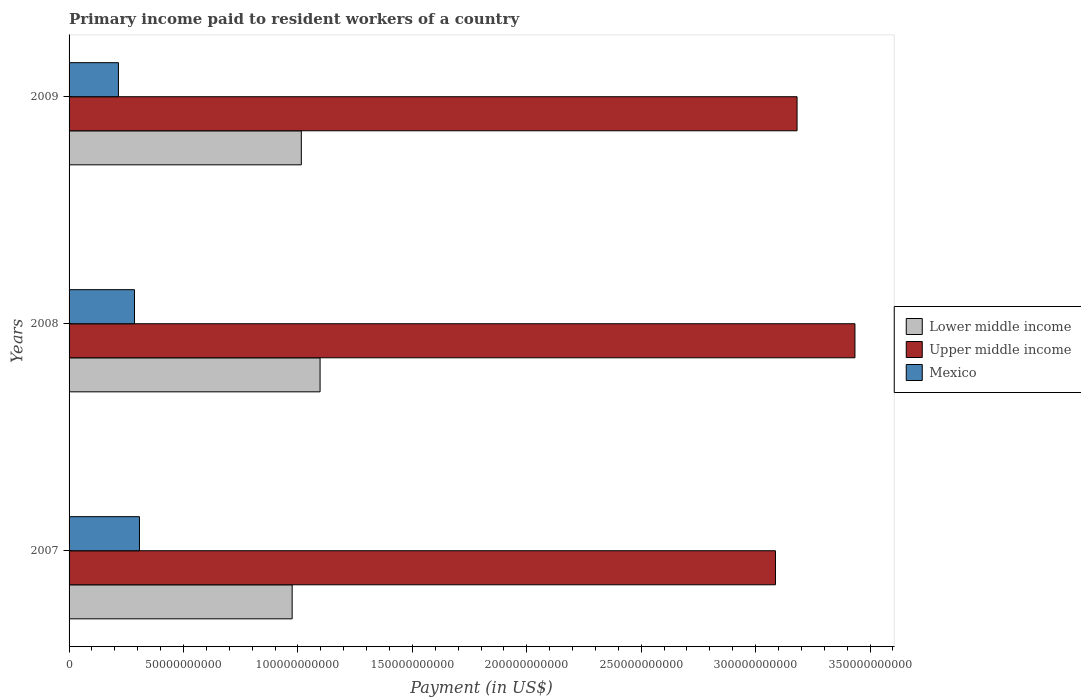How many different coloured bars are there?
Offer a very short reply. 3. How many groups of bars are there?
Make the answer very short. 3. How many bars are there on the 3rd tick from the top?
Give a very brief answer. 3. What is the label of the 2nd group of bars from the top?
Give a very brief answer. 2008. What is the amount paid to workers in Upper middle income in 2008?
Your answer should be very brief. 3.43e+11. Across all years, what is the maximum amount paid to workers in Mexico?
Your answer should be compact. 3.08e+1. Across all years, what is the minimum amount paid to workers in Lower middle income?
Your answer should be very brief. 9.75e+1. In which year was the amount paid to workers in Lower middle income maximum?
Your answer should be compact. 2008. What is the total amount paid to workers in Lower middle income in the graph?
Give a very brief answer. 3.09e+11. What is the difference between the amount paid to workers in Upper middle income in 2007 and that in 2008?
Ensure brevity in your answer.  -3.47e+1. What is the difference between the amount paid to workers in Lower middle income in 2009 and the amount paid to workers in Mexico in 2008?
Make the answer very short. 7.29e+1. What is the average amount paid to workers in Upper middle income per year?
Provide a short and direct response. 3.23e+11. In the year 2007, what is the difference between the amount paid to workers in Upper middle income and amount paid to workers in Mexico?
Provide a succinct answer. 2.78e+11. In how many years, is the amount paid to workers in Upper middle income greater than 110000000000 US$?
Offer a very short reply. 3. What is the ratio of the amount paid to workers in Upper middle income in 2007 to that in 2008?
Offer a terse response. 0.9. Is the amount paid to workers in Upper middle income in 2007 less than that in 2009?
Your response must be concise. Yes. What is the difference between the highest and the second highest amount paid to workers in Upper middle income?
Offer a very short reply. 2.53e+1. What is the difference between the highest and the lowest amount paid to workers in Upper middle income?
Your answer should be very brief. 3.47e+1. In how many years, is the amount paid to workers in Lower middle income greater than the average amount paid to workers in Lower middle income taken over all years?
Your answer should be compact. 1. Is the sum of the amount paid to workers in Lower middle income in 2007 and 2009 greater than the maximum amount paid to workers in Mexico across all years?
Give a very brief answer. Yes. What does the 3rd bar from the top in 2009 represents?
Your answer should be very brief. Lower middle income. What does the 2nd bar from the bottom in 2008 represents?
Offer a terse response. Upper middle income. Are the values on the major ticks of X-axis written in scientific E-notation?
Provide a short and direct response. No. Where does the legend appear in the graph?
Make the answer very short. Center right. How are the legend labels stacked?
Offer a terse response. Vertical. What is the title of the graph?
Provide a succinct answer. Primary income paid to resident workers of a country. Does "Peru" appear as one of the legend labels in the graph?
Provide a succinct answer. No. What is the label or title of the X-axis?
Your response must be concise. Payment (in US$). What is the Payment (in US$) of Lower middle income in 2007?
Ensure brevity in your answer.  9.75e+1. What is the Payment (in US$) of Upper middle income in 2007?
Your answer should be compact. 3.09e+11. What is the Payment (in US$) in Mexico in 2007?
Provide a short and direct response. 3.08e+1. What is the Payment (in US$) in Lower middle income in 2008?
Keep it short and to the point. 1.10e+11. What is the Payment (in US$) of Upper middle income in 2008?
Your response must be concise. 3.43e+11. What is the Payment (in US$) in Mexico in 2008?
Provide a short and direct response. 2.86e+1. What is the Payment (in US$) of Lower middle income in 2009?
Offer a very short reply. 1.01e+11. What is the Payment (in US$) of Upper middle income in 2009?
Your response must be concise. 3.18e+11. What is the Payment (in US$) in Mexico in 2009?
Provide a short and direct response. 2.16e+1. Across all years, what is the maximum Payment (in US$) in Lower middle income?
Your response must be concise. 1.10e+11. Across all years, what is the maximum Payment (in US$) of Upper middle income?
Your answer should be very brief. 3.43e+11. Across all years, what is the maximum Payment (in US$) of Mexico?
Make the answer very short. 3.08e+1. Across all years, what is the minimum Payment (in US$) of Lower middle income?
Give a very brief answer. 9.75e+1. Across all years, what is the minimum Payment (in US$) in Upper middle income?
Offer a very short reply. 3.09e+11. Across all years, what is the minimum Payment (in US$) in Mexico?
Provide a succinct answer. 2.16e+1. What is the total Payment (in US$) of Lower middle income in the graph?
Make the answer very short. 3.09e+11. What is the total Payment (in US$) of Upper middle income in the graph?
Your response must be concise. 9.70e+11. What is the total Payment (in US$) of Mexico in the graph?
Your answer should be compact. 8.09e+1. What is the difference between the Payment (in US$) of Lower middle income in 2007 and that in 2008?
Your answer should be very brief. -1.22e+1. What is the difference between the Payment (in US$) in Upper middle income in 2007 and that in 2008?
Your answer should be compact. -3.47e+1. What is the difference between the Payment (in US$) in Mexico in 2007 and that in 2008?
Keep it short and to the point. 2.18e+09. What is the difference between the Payment (in US$) of Lower middle income in 2007 and that in 2009?
Make the answer very short. -4.01e+09. What is the difference between the Payment (in US$) in Upper middle income in 2007 and that in 2009?
Your answer should be very brief. -9.44e+09. What is the difference between the Payment (in US$) in Mexico in 2007 and that in 2009?
Ensure brevity in your answer.  9.19e+09. What is the difference between the Payment (in US$) of Lower middle income in 2008 and that in 2009?
Offer a very short reply. 8.19e+09. What is the difference between the Payment (in US$) in Upper middle income in 2008 and that in 2009?
Make the answer very short. 2.53e+1. What is the difference between the Payment (in US$) of Mexico in 2008 and that in 2009?
Keep it short and to the point. 7.01e+09. What is the difference between the Payment (in US$) of Lower middle income in 2007 and the Payment (in US$) of Upper middle income in 2008?
Offer a very short reply. -2.46e+11. What is the difference between the Payment (in US$) in Lower middle income in 2007 and the Payment (in US$) in Mexico in 2008?
Provide a succinct answer. 6.89e+1. What is the difference between the Payment (in US$) of Upper middle income in 2007 and the Payment (in US$) of Mexico in 2008?
Ensure brevity in your answer.  2.80e+11. What is the difference between the Payment (in US$) of Lower middle income in 2007 and the Payment (in US$) of Upper middle income in 2009?
Ensure brevity in your answer.  -2.21e+11. What is the difference between the Payment (in US$) in Lower middle income in 2007 and the Payment (in US$) in Mexico in 2009?
Provide a short and direct response. 7.59e+1. What is the difference between the Payment (in US$) in Upper middle income in 2007 and the Payment (in US$) in Mexico in 2009?
Your answer should be compact. 2.87e+11. What is the difference between the Payment (in US$) in Lower middle income in 2008 and the Payment (in US$) in Upper middle income in 2009?
Your response must be concise. -2.08e+11. What is the difference between the Payment (in US$) of Lower middle income in 2008 and the Payment (in US$) of Mexico in 2009?
Give a very brief answer. 8.81e+1. What is the difference between the Payment (in US$) of Upper middle income in 2008 and the Payment (in US$) of Mexico in 2009?
Provide a short and direct response. 3.22e+11. What is the average Payment (in US$) of Lower middle income per year?
Offer a very short reply. 1.03e+11. What is the average Payment (in US$) of Upper middle income per year?
Your answer should be compact. 3.23e+11. What is the average Payment (in US$) of Mexico per year?
Keep it short and to the point. 2.70e+1. In the year 2007, what is the difference between the Payment (in US$) of Lower middle income and Payment (in US$) of Upper middle income?
Give a very brief answer. -2.11e+11. In the year 2007, what is the difference between the Payment (in US$) of Lower middle income and Payment (in US$) of Mexico?
Your response must be concise. 6.67e+1. In the year 2007, what is the difference between the Payment (in US$) of Upper middle income and Payment (in US$) of Mexico?
Your answer should be compact. 2.78e+11. In the year 2008, what is the difference between the Payment (in US$) in Lower middle income and Payment (in US$) in Upper middle income?
Make the answer very short. -2.34e+11. In the year 2008, what is the difference between the Payment (in US$) of Lower middle income and Payment (in US$) of Mexico?
Provide a short and direct response. 8.11e+1. In the year 2008, what is the difference between the Payment (in US$) in Upper middle income and Payment (in US$) in Mexico?
Provide a short and direct response. 3.15e+11. In the year 2009, what is the difference between the Payment (in US$) of Lower middle income and Payment (in US$) of Upper middle income?
Your response must be concise. -2.17e+11. In the year 2009, what is the difference between the Payment (in US$) of Lower middle income and Payment (in US$) of Mexico?
Your answer should be compact. 7.99e+1. In the year 2009, what is the difference between the Payment (in US$) of Upper middle income and Payment (in US$) of Mexico?
Make the answer very short. 2.97e+11. What is the ratio of the Payment (in US$) of Lower middle income in 2007 to that in 2008?
Your answer should be very brief. 0.89. What is the ratio of the Payment (in US$) of Upper middle income in 2007 to that in 2008?
Make the answer very short. 0.9. What is the ratio of the Payment (in US$) in Mexico in 2007 to that in 2008?
Your answer should be very brief. 1.08. What is the ratio of the Payment (in US$) of Lower middle income in 2007 to that in 2009?
Your response must be concise. 0.96. What is the ratio of the Payment (in US$) in Upper middle income in 2007 to that in 2009?
Give a very brief answer. 0.97. What is the ratio of the Payment (in US$) in Mexico in 2007 to that in 2009?
Your answer should be compact. 1.43. What is the ratio of the Payment (in US$) in Lower middle income in 2008 to that in 2009?
Your response must be concise. 1.08. What is the ratio of the Payment (in US$) of Upper middle income in 2008 to that in 2009?
Your answer should be compact. 1.08. What is the ratio of the Payment (in US$) in Mexico in 2008 to that in 2009?
Keep it short and to the point. 1.33. What is the difference between the highest and the second highest Payment (in US$) in Lower middle income?
Keep it short and to the point. 8.19e+09. What is the difference between the highest and the second highest Payment (in US$) in Upper middle income?
Make the answer very short. 2.53e+1. What is the difference between the highest and the second highest Payment (in US$) in Mexico?
Ensure brevity in your answer.  2.18e+09. What is the difference between the highest and the lowest Payment (in US$) of Lower middle income?
Offer a very short reply. 1.22e+1. What is the difference between the highest and the lowest Payment (in US$) in Upper middle income?
Keep it short and to the point. 3.47e+1. What is the difference between the highest and the lowest Payment (in US$) of Mexico?
Ensure brevity in your answer.  9.19e+09. 